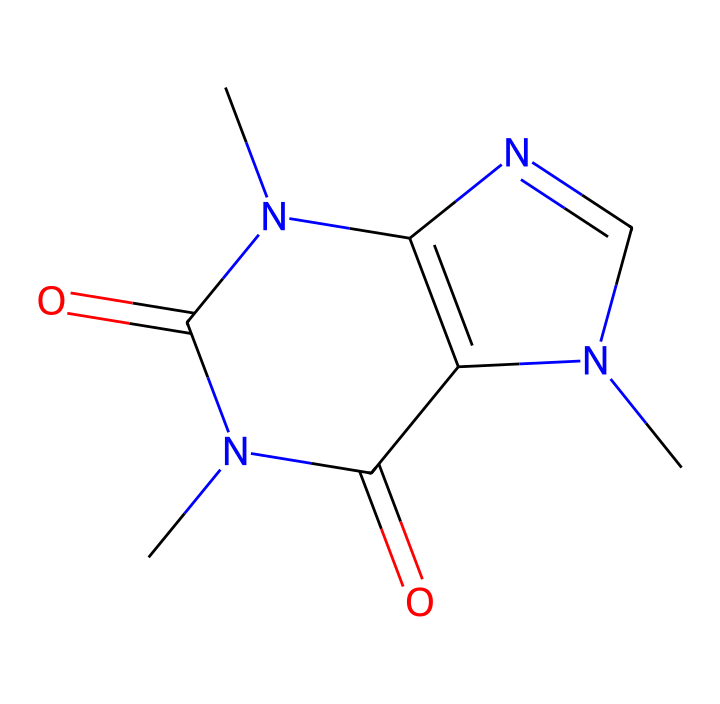What is the molecular formula of caffeine? To determine the molecular formula, we can analyze the SMILES representation, counting each atom type. The formula comprises 8 carbon (C) atoms, 10 hydrogen (H) atoms, 4 nitrogen (N) atoms, and 2 oxygen (O) atoms, leading to the formula C8H10N4O2.
Answer: C8H10N4O2 How many nitrogen atoms are in caffeine? By inspecting the SMILES representation for 'N', we see that there are a total of 4 nitrogen atoms.
Answer: 4 What type of functional groups are present in caffeine? The structure shows two carbonyl groups (C=O) indicating the presence of amide functional groups, characteristic of imides. This can be seen where nitrogen atoms are bonded to carbonyls in the chemical structure.
Answer: amide How many rings are present in the caffeine structure? By analyzing the SMILES representation, we see two distinct ring structures can be identified due to the presence of 'C' and 'N' linking in cyclical fashion, confirming that there are two rings in the caffeine molecule.
Answer: 2 What distinguishes caffeine as an imide compound? Caffeine is classified as an imide because its structure contains carbonyl groups (C=O) directly attached to nitrogen atoms (N), which is a defining characteristic of imide compounds, visible in the arrangement of carbonyls in conjunction with nitrogen.
Answer: carbonyl groups 